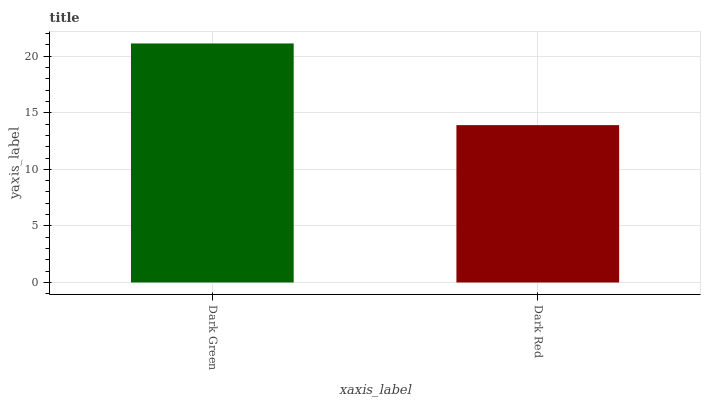Is Dark Red the minimum?
Answer yes or no. Yes. Is Dark Green the maximum?
Answer yes or no. Yes. Is Dark Red the maximum?
Answer yes or no. No. Is Dark Green greater than Dark Red?
Answer yes or no. Yes. Is Dark Red less than Dark Green?
Answer yes or no. Yes. Is Dark Red greater than Dark Green?
Answer yes or no. No. Is Dark Green less than Dark Red?
Answer yes or no. No. Is Dark Green the high median?
Answer yes or no. Yes. Is Dark Red the low median?
Answer yes or no. Yes. Is Dark Red the high median?
Answer yes or no. No. Is Dark Green the low median?
Answer yes or no. No. 